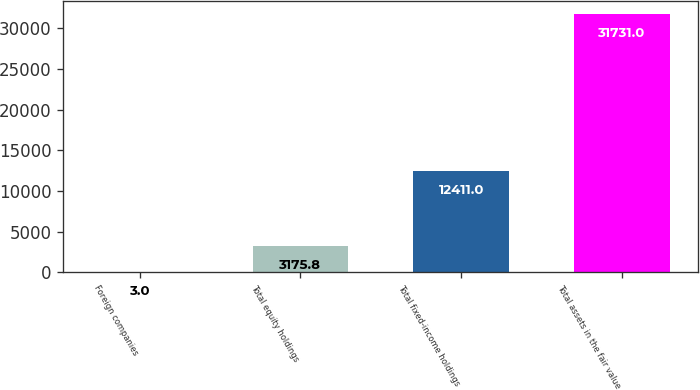Convert chart. <chart><loc_0><loc_0><loc_500><loc_500><bar_chart><fcel>Foreign companies<fcel>Total equity holdings<fcel>Total fixed-income holdings<fcel>Total assets in the fair value<nl><fcel>3<fcel>3175.8<fcel>12411<fcel>31731<nl></chart> 